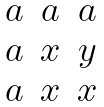Convert formula to latex. <formula><loc_0><loc_0><loc_500><loc_500>\begin{matrix} a & a & a \\ a & x & y \\ a & x & x \end{matrix}</formula> 